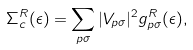Convert formula to latex. <formula><loc_0><loc_0><loc_500><loc_500>\Sigma ^ { R } _ { c } ( \epsilon ) = \sum _ { { p } \sigma } | V _ { { p } \sigma } | ^ { 2 } g ^ { R } _ { { p } \sigma } ( \epsilon ) ,</formula> 